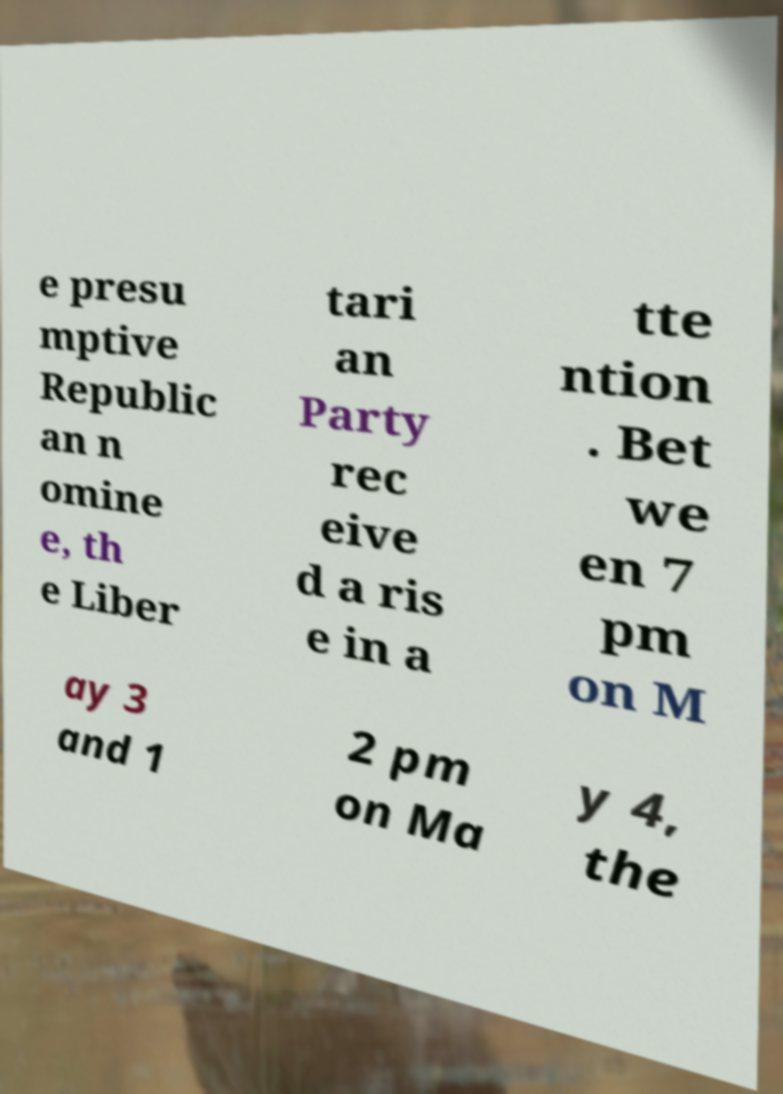Please read and relay the text visible in this image. What does it say? e presu mptive Republic an n omine e, th e Liber tari an Party rec eive d a ris e in a tte ntion . Bet we en 7 pm on M ay 3 and 1 2 pm on Ma y 4, the 